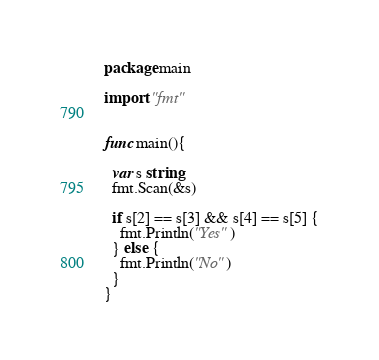Convert code to text. <code><loc_0><loc_0><loc_500><loc_500><_Go_>package main

import "fmt"


func main(){
  
  var s string
  fmt.Scan(&s)
  
  if s[2] == s[3] && s[4] == s[5] {
    fmt.Println("Yes") 
  } else {
    fmt.Println("No")
  }
}</code> 